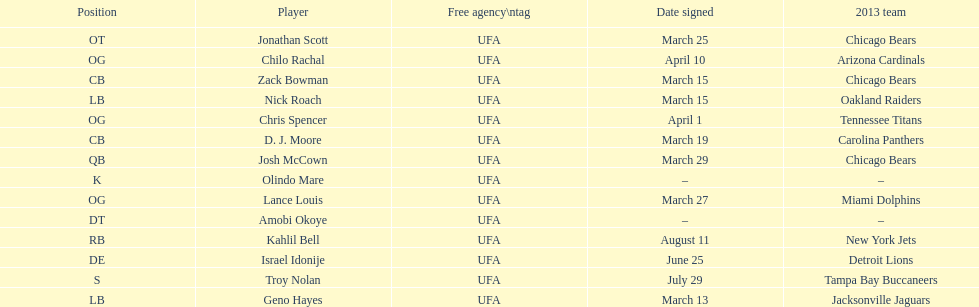During march, how many players were acquired through signing? 7. 